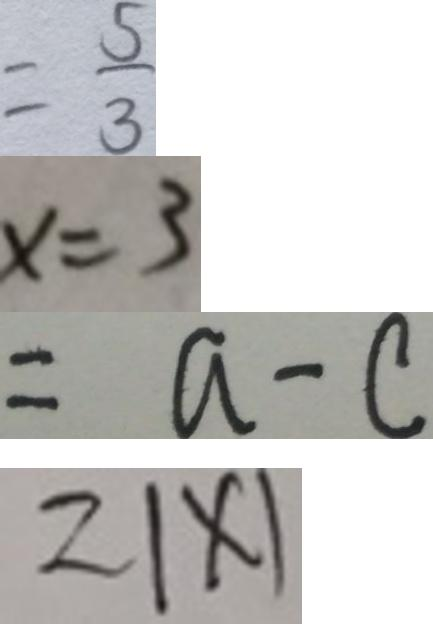Convert formula to latex. <formula><loc_0><loc_0><loc_500><loc_500>= \frac { 5 } { 3 } 
 x = 3 
 = a - c 
 2 \vert x \vert</formula> 